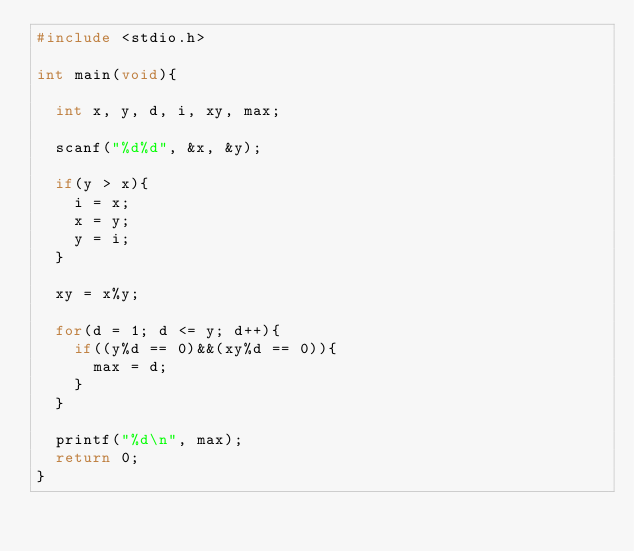Convert code to text. <code><loc_0><loc_0><loc_500><loc_500><_C_>#include <stdio.h>

int main(void){

  int x, y, d, i, xy, max;

  scanf("%d%d", &x, &y);
  
  if(y > x){
    i = x;
    x = y;
    y = i;
  }

  xy = x%y;

  for(d = 1; d <= y; d++){
    if((y%d == 0)&&(xy%d == 0)){
      max = d;
    }
  }

  printf("%d\n", max);
  return 0;
}</code> 